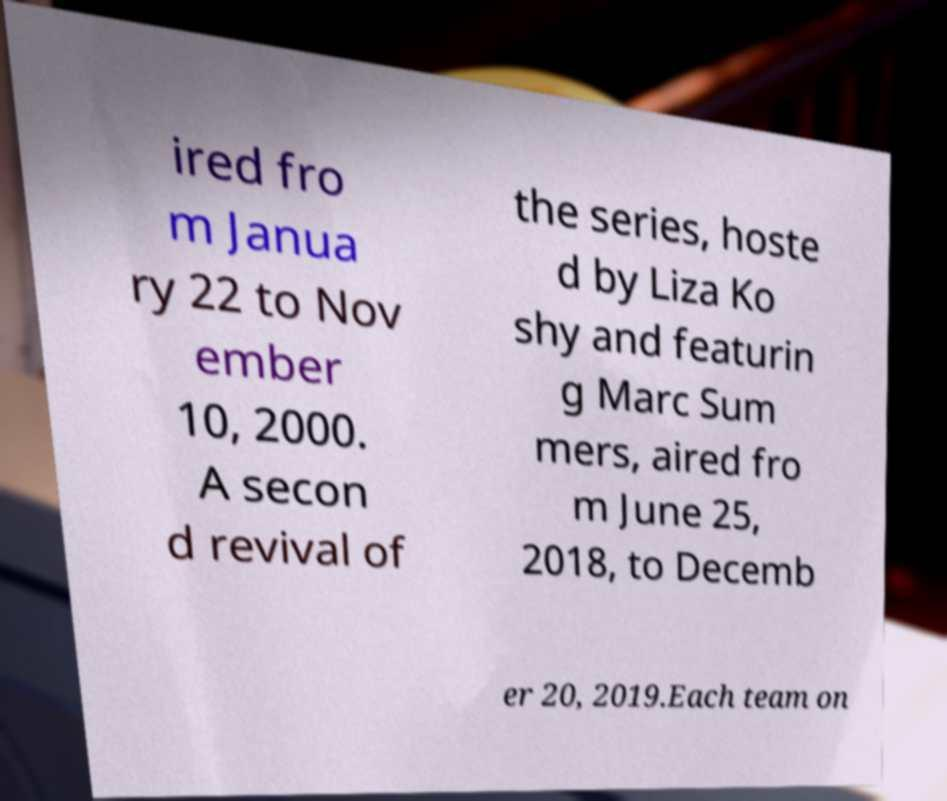Can you accurately transcribe the text from the provided image for me? ired fro m Janua ry 22 to Nov ember 10, 2000. A secon d revival of the series, hoste d by Liza Ko shy and featurin g Marc Sum mers, aired fro m June 25, 2018, to Decemb er 20, 2019.Each team on 